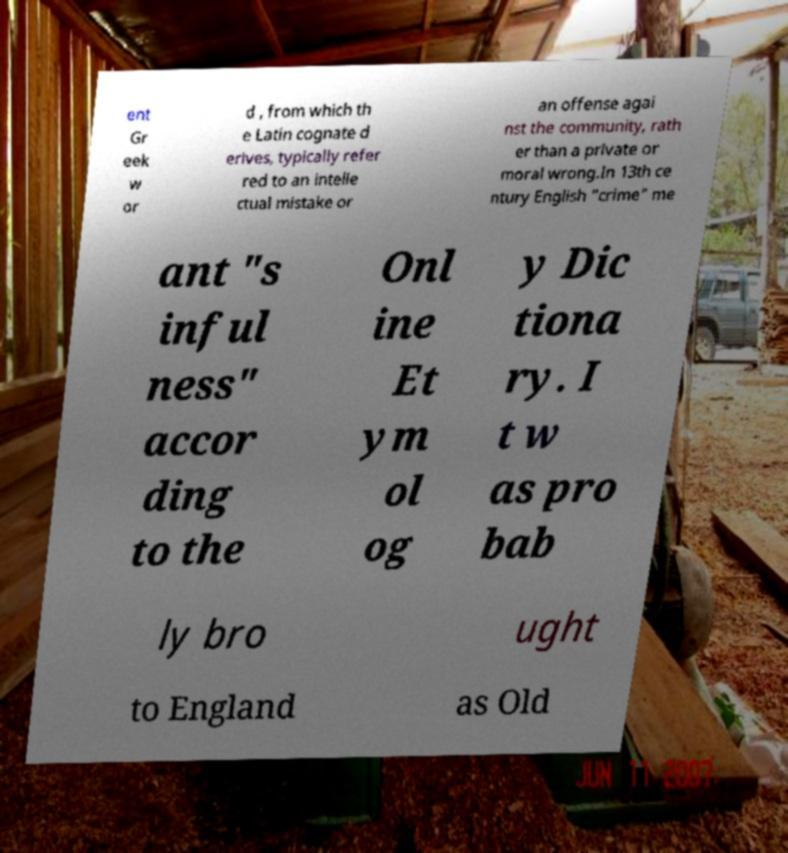Can you accurately transcribe the text from the provided image for me? ent Gr eek w or d , from which th e Latin cognate d erives, typically refer red to an intelle ctual mistake or an offense agai nst the community, rath er than a private or moral wrong.In 13th ce ntury English "crime" me ant "s inful ness" accor ding to the Onl ine Et ym ol og y Dic tiona ry. I t w as pro bab ly bro ught to England as Old 